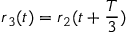Convert formula to latex. <formula><loc_0><loc_0><loc_500><loc_500>r _ { 3 } ( t ) = r _ { 2 } ( t + \frac { T } { 3 } )</formula> 